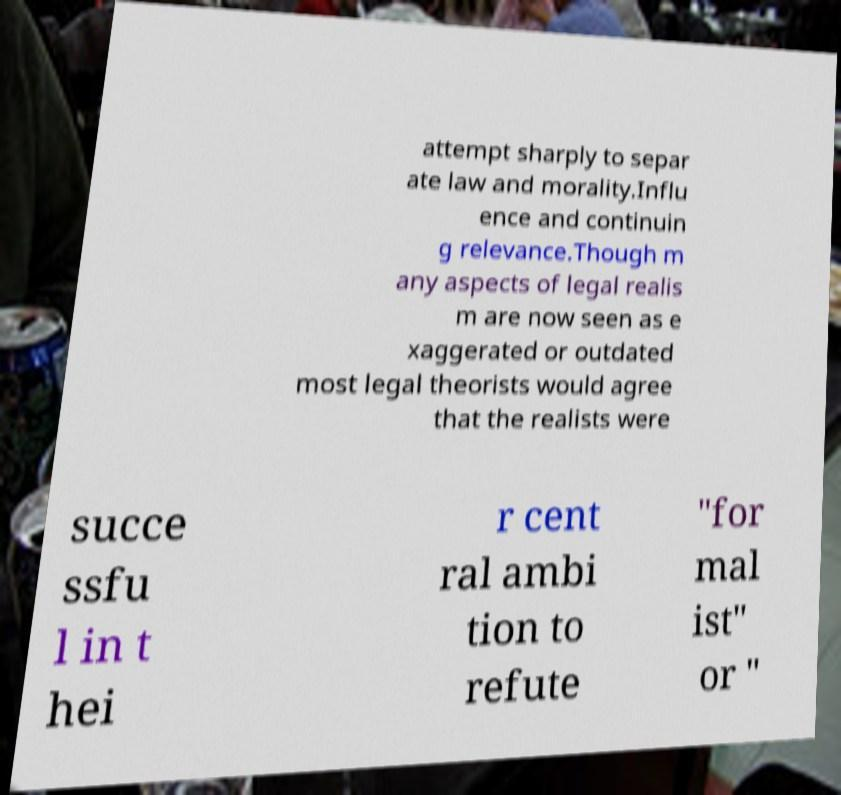There's text embedded in this image that I need extracted. Can you transcribe it verbatim? attempt sharply to separ ate law and morality.Influ ence and continuin g relevance.Though m any aspects of legal realis m are now seen as e xaggerated or outdated most legal theorists would agree that the realists were succe ssfu l in t hei r cent ral ambi tion to refute "for mal ist" or " 